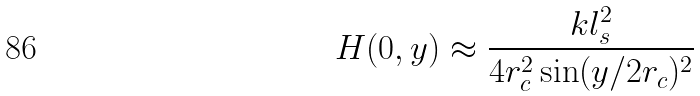Convert formula to latex. <formula><loc_0><loc_0><loc_500><loc_500>H ( 0 , y ) \approx \frac { k l _ { s } ^ { 2 } } { 4 r _ { c } ^ { 2 } \sin ( y / 2 r _ { c } ) ^ { 2 } }</formula> 